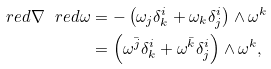<formula> <loc_0><loc_0><loc_500><loc_500>\ r e d { \nabla } \ r e d { \omega } & = - \left ( \omega _ { j } \delta ^ { i } _ { k } + \omega _ { k } \delta ^ { i } _ { j } \right ) \wedge \omega ^ { k } \\ & = \left ( \omega ^ { \bar { j } } \delta ^ { i } _ { k } + \omega ^ { \bar { k } } \delta ^ { i } _ { j } \right ) \wedge \omega ^ { k } ,</formula> 